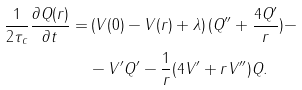Convert formula to latex. <formula><loc_0><loc_0><loc_500><loc_500>\frac { 1 } { 2 \tau _ { c } } \frac { \partial Q ( r ) } { \partial t } = & \left ( V ( 0 ) - V ( r ) + \lambda \right ) ( Q ^ { \prime \prime } + \frac { 4 Q ^ { \prime } } { r } ) - \\ & - V ^ { \prime } Q ^ { \prime } - \frac { 1 } { r } ( 4 V ^ { \prime } + r V ^ { \prime \prime } ) Q .</formula> 